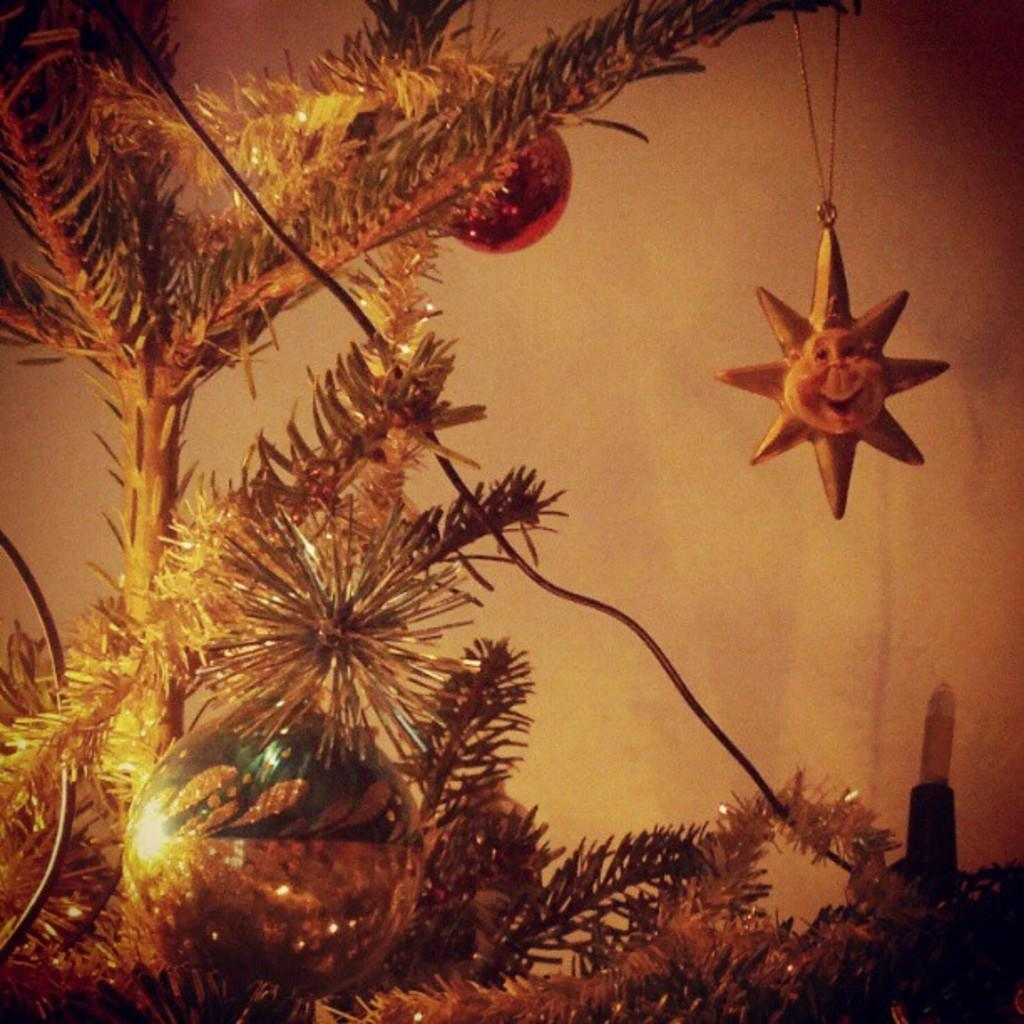What type of decorations can be seen on the tree in the image? There are decorative balls on a tree in the image. What object is located on the right side of the image? There is a locket on the right side of the image. What type of song can be heard coming from the river in the image? There is no river present in the image, so it's not possible to determine what, if any, song might be heard. 